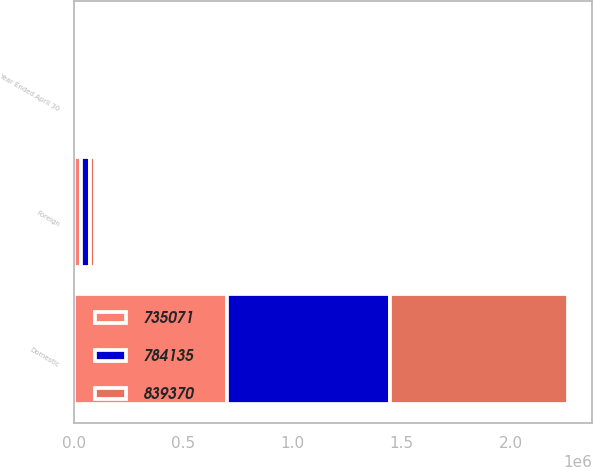Convert chart. <chart><loc_0><loc_0><loc_500><loc_500><stacked_bar_chart><ecel><fcel>Year Ended April 30<fcel>Domestic<fcel>Foreign<nl><fcel>784135<fcel>2010<fcel>745912<fcel>38223<nl><fcel>839370<fcel>2009<fcel>815614<fcel>23756<nl><fcel>735071<fcel>2008<fcel>700162<fcel>34909<nl></chart> 